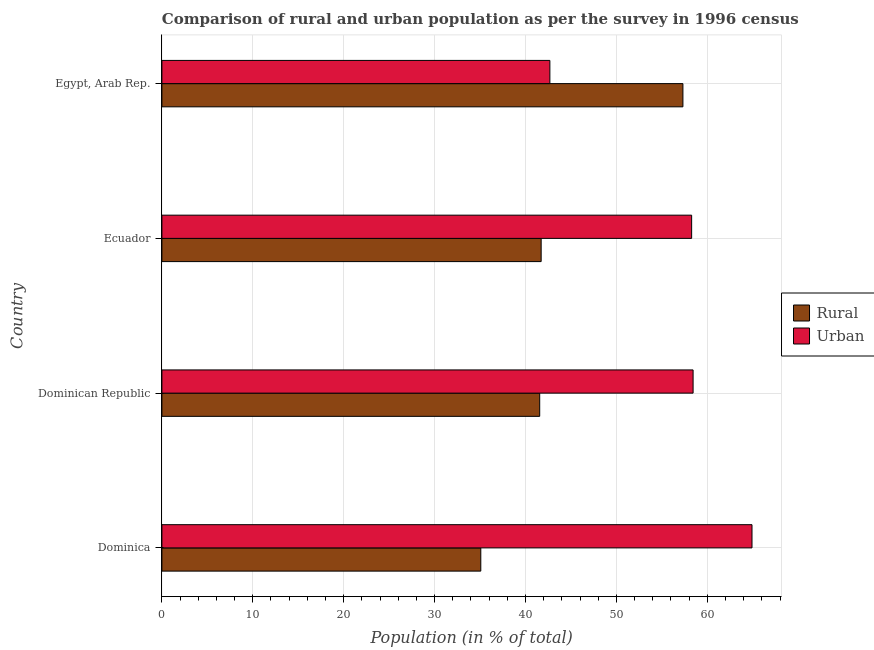How many groups of bars are there?
Offer a very short reply. 4. Are the number of bars per tick equal to the number of legend labels?
Your answer should be compact. Yes. How many bars are there on the 4th tick from the bottom?
Make the answer very short. 2. What is the label of the 1st group of bars from the top?
Give a very brief answer. Egypt, Arab Rep. In how many cases, is the number of bars for a given country not equal to the number of legend labels?
Offer a very short reply. 0. What is the rural population in Egypt, Arab Rep.?
Offer a very short reply. 57.32. Across all countries, what is the maximum urban population?
Your answer should be very brief. 64.92. Across all countries, what is the minimum urban population?
Give a very brief answer. 42.68. In which country was the urban population maximum?
Your answer should be compact. Dominica. In which country was the urban population minimum?
Provide a short and direct response. Egypt, Arab Rep. What is the total urban population in the graph?
Keep it short and to the point. 224.31. What is the difference between the urban population in Dominican Republic and that in Egypt, Arab Rep.?
Offer a terse response. 15.76. What is the difference between the urban population in Egypt, Arab Rep. and the rural population in Dominica?
Give a very brief answer. 7.6. What is the average urban population per country?
Provide a short and direct response. 56.08. What is the difference between the rural population and urban population in Egypt, Arab Rep.?
Your response must be concise. 14.64. What is the ratio of the rural population in Ecuador to that in Egypt, Arab Rep.?
Your answer should be very brief. 0.73. Is the urban population in Dominican Republic less than that in Egypt, Arab Rep.?
Provide a short and direct response. No. What is the difference between the highest and the second highest urban population?
Provide a short and direct response. 6.48. What is the difference between the highest and the lowest rural population?
Provide a short and direct response. 22.24. What does the 2nd bar from the top in Dominican Republic represents?
Offer a very short reply. Rural. What does the 1st bar from the bottom in Egypt, Arab Rep. represents?
Offer a terse response. Rural. How many bars are there?
Keep it short and to the point. 8. Are all the bars in the graph horizontal?
Your answer should be very brief. Yes. Are the values on the major ticks of X-axis written in scientific E-notation?
Keep it short and to the point. No. Does the graph contain any zero values?
Offer a terse response. No. Does the graph contain grids?
Keep it short and to the point. Yes. How many legend labels are there?
Your response must be concise. 2. How are the legend labels stacked?
Keep it short and to the point. Vertical. What is the title of the graph?
Offer a very short reply. Comparison of rural and urban population as per the survey in 1996 census. Does "RDB nonconcessional" appear as one of the legend labels in the graph?
Offer a terse response. No. What is the label or title of the X-axis?
Ensure brevity in your answer.  Population (in % of total). What is the Population (in % of total) of Rural in Dominica?
Offer a terse response. 35.08. What is the Population (in % of total) of Urban in Dominica?
Provide a succinct answer. 64.92. What is the Population (in % of total) in Rural in Dominican Republic?
Keep it short and to the point. 41.56. What is the Population (in % of total) in Urban in Dominican Republic?
Your answer should be compact. 58.44. What is the Population (in % of total) in Rural in Ecuador?
Keep it short and to the point. 41.72. What is the Population (in % of total) in Urban in Ecuador?
Offer a terse response. 58.28. What is the Population (in % of total) in Rural in Egypt, Arab Rep.?
Offer a very short reply. 57.32. What is the Population (in % of total) of Urban in Egypt, Arab Rep.?
Make the answer very short. 42.68. Across all countries, what is the maximum Population (in % of total) in Rural?
Provide a succinct answer. 57.32. Across all countries, what is the maximum Population (in % of total) in Urban?
Keep it short and to the point. 64.92. Across all countries, what is the minimum Population (in % of total) of Rural?
Provide a succinct answer. 35.08. Across all countries, what is the minimum Population (in % of total) of Urban?
Give a very brief answer. 42.68. What is the total Population (in % of total) in Rural in the graph?
Make the answer very short. 175.69. What is the total Population (in % of total) in Urban in the graph?
Give a very brief answer. 224.31. What is the difference between the Population (in % of total) of Rural in Dominica and that in Dominican Republic?
Ensure brevity in your answer.  -6.48. What is the difference between the Population (in % of total) in Urban in Dominica and that in Dominican Republic?
Ensure brevity in your answer.  6.48. What is the difference between the Population (in % of total) in Rural in Dominica and that in Ecuador?
Ensure brevity in your answer.  -6.64. What is the difference between the Population (in % of total) of Urban in Dominica and that in Ecuador?
Make the answer very short. 6.64. What is the difference between the Population (in % of total) in Rural in Dominica and that in Egypt, Arab Rep.?
Make the answer very short. -22.24. What is the difference between the Population (in % of total) in Urban in Dominica and that in Egypt, Arab Rep.?
Make the answer very short. 22.24. What is the difference between the Population (in % of total) of Rural in Dominican Republic and that in Ecuador?
Keep it short and to the point. -0.16. What is the difference between the Population (in % of total) of Urban in Dominican Republic and that in Ecuador?
Give a very brief answer. 0.16. What is the difference between the Population (in % of total) in Rural in Dominican Republic and that in Egypt, Arab Rep.?
Give a very brief answer. -15.76. What is the difference between the Population (in % of total) in Urban in Dominican Republic and that in Egypt, Arab Rep.?
Provide a short and direct response. 15.76. What is the difference between the Population (in % of total) in Rural in Ecuador and that in Egypt, Arab Rep.?
Your response must be concise. -15.6. What is the difference between the Population (in % of total) of Urban in Ecuador and that in Egypt, Arab Rep.?
Your answer should be very brief. 15.6. What is the difference between the Population (in % of total) of Rural in Dominica and the Population (in % of total) of Urban in Dominican Republic?
Ensure brevity in your answer.  -23.36. What is the difference between the Population (in % of total) of Rural in Dominica and the Population (in % of total) of Urban in Ecuador?
Give a very brief answer. -23.2. What is the difference between the Population (in % of total) of Rural in Dominica and the Population (in % of total) of Urban in Egypt, Arab Rep.?
Make the answer very short. -7.6. What is the difference between the Population (in % of total) of Rural in Dominican Republic and the Population (in % of total) of Urban in Ecuador?
Your answer should be very brief. -16.71. What is the difference between the Population (in % of total) in Rural in Dominican Republic and the Population (in % of total) in Urban in Egypt, Arab Rep.?
Your answer should be compact. -1.12. What is the difference between the Population (in % of total) in Rural in Ecuador and the Population (in % of total) in Urban in Egypt, Arab Rep.?
Provide a short and direct response. -0.96. What is the average Population (in % of total) in Rural per country?
Make the answer very short. 43.92. What is the average Population (in % of total) of Urban per country?
Your answer should be compact. 56.08. What is the difference between the Population (in % of total) of Rural and Population (in % of total) of Urban in Dominica?
Keep it short and to the point. -29.84. What is the difference between the Population (in % of total) in Rural and Population (in % of total) in Urban in Dominican Republic?
Your answer should be compact. -16.87. What is the difference between the Population (in % of total) in Rural and Population (in % of total) in Urban in Ecuador?
Offer a terse response. -16.55. What is the difference between the Population (in % of total) of Rural and Population (in % of total) of Urban in Egypt, Arab Rep.?
Give a very brief answer. 14.64. What is the ratio of the Population (in % of total) in Rural in Dominica to that in Dominican Republic?
Offer a very short reply. 0.84. What is the ratio of the Population (in % of total) in Urban in Dominica to that in Dominican Republic?
Your answer should be compact. 1.11. What is the ratio of the Population (in % of total) of Rural in Dominica to that in Ecuador?
Keep it short and to the point. 0.84. What is the ratio of the Population (in % of total) of Urban in Dominica to that in Ecuador?
Offer a terse response. 1.11. What is the ratio of the Population (in % of total) of Rural in Dominica to that in Egypt, Arab Rep.?
Keep it short and to the point. 0.61. What is the ratio of the Population (in % of total) in Urban in Dominica to that in Egypt, Arab Rep.?
Ensure brevity in your answer.  1.52. What is the ratio of the Population (in % of total) in Rural in Dominican Republic to that in Egypt, Arab Rep.?
Make the answer very short. 0.73. What is the ratio of the Population (in % of total) in Urban in Dominican Republic to that in Egypt, Arab Rep.?
Ensure brevity in your answer.  1.37. What is the ratio of the Population (in % of total) in Rural in Ecuador to that in Egypt, Arab Rep.?
Your answer should be compact. 0.73. What is the ratio of the Population (in % of total) of Urban in Ecuador to that in Egypt, Arab Rep.?
Your answer should be very brief. 1.37. What is the difference between the highest and the second highest Population (in % of total) in Rural?
Offer a terse response. 15.6. What is the difference between the highest and the second highest Population (in % of total) of Urban?
Provide a short and direct response. 6.48. What is the difference between the highest and the lowest Population (in % of total) of Rural?
Provide a short and direct response. 22.24. What is the difference between the highest and the lowest Population (in % of total) in Urban?
Give a very brief answer. 22.24. 